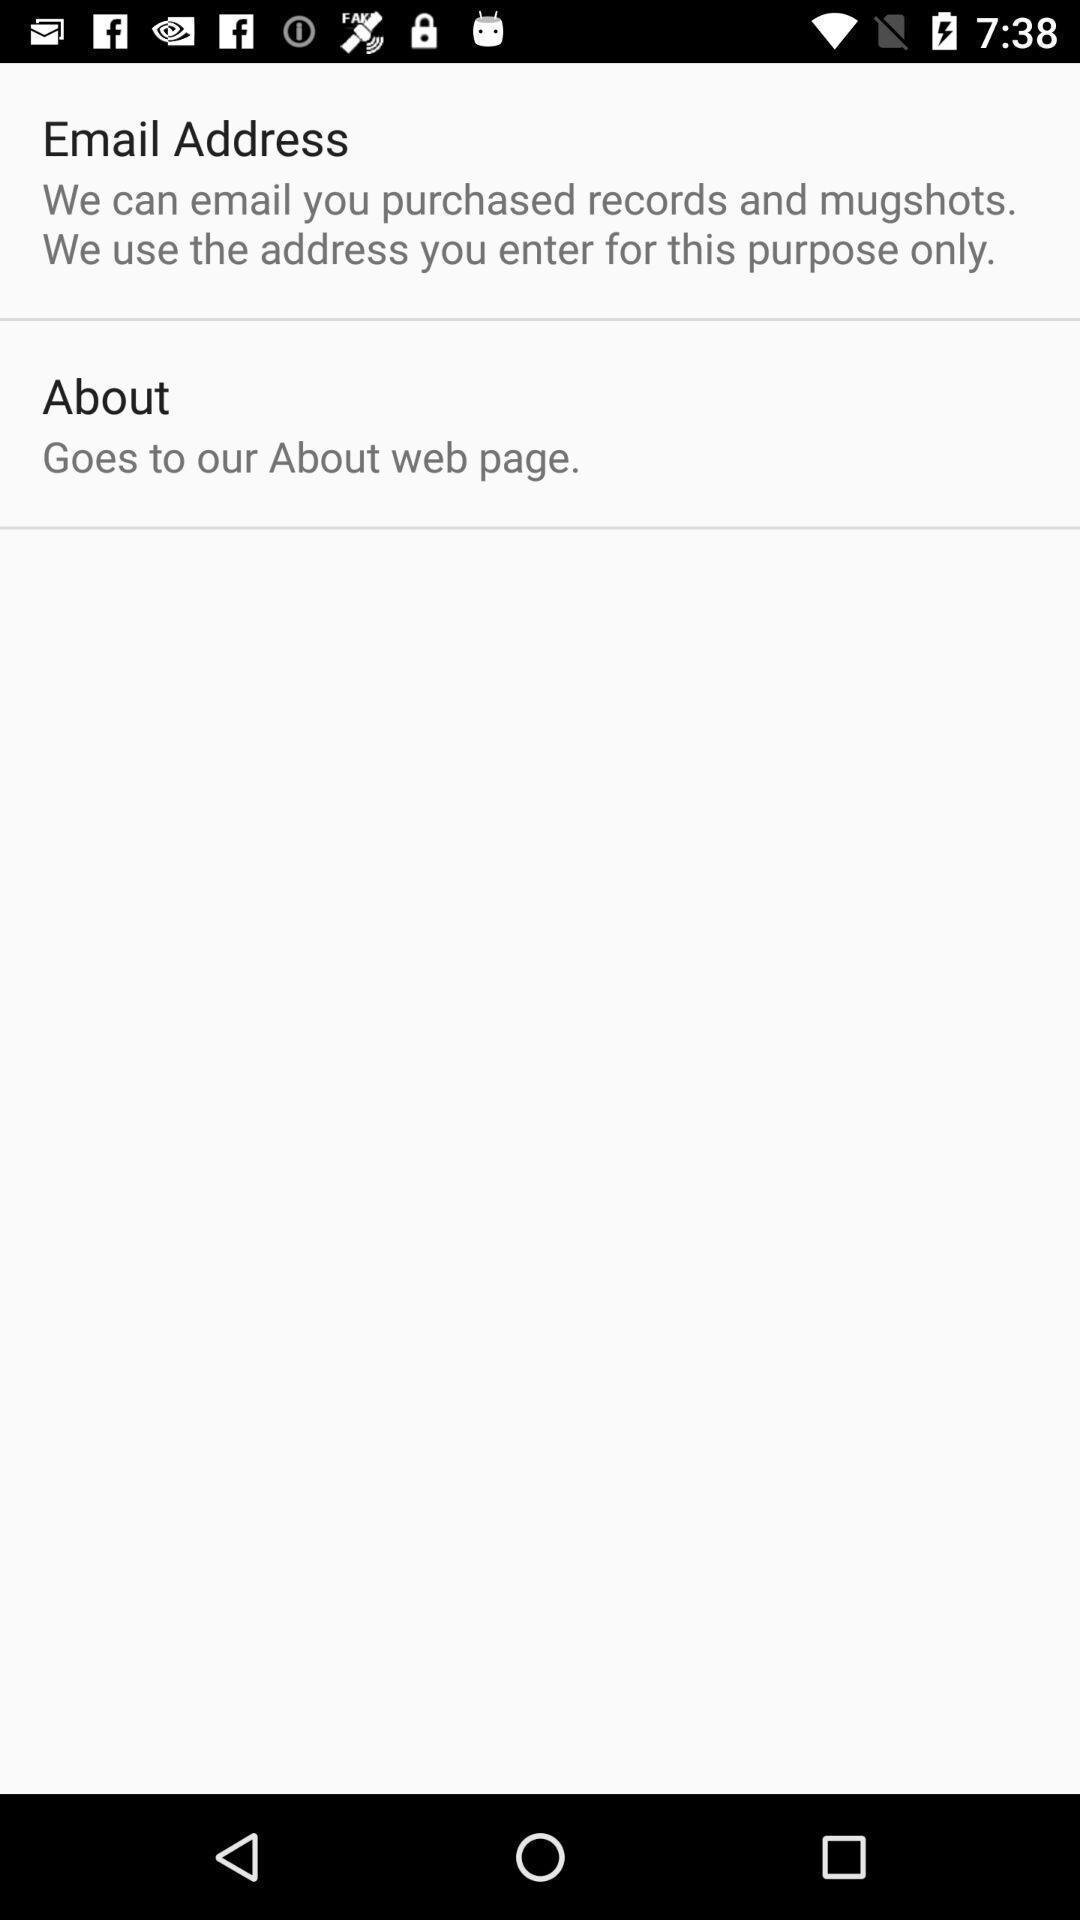Explain the elements present in this screenshot. Page displaying options like email and about. 